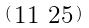<formula> <loc_0><loc_0><loc_500><loc_500>\begin{psmallmatrix} 1 1 & 2 5 \end{psmallmatrix}</formula> 